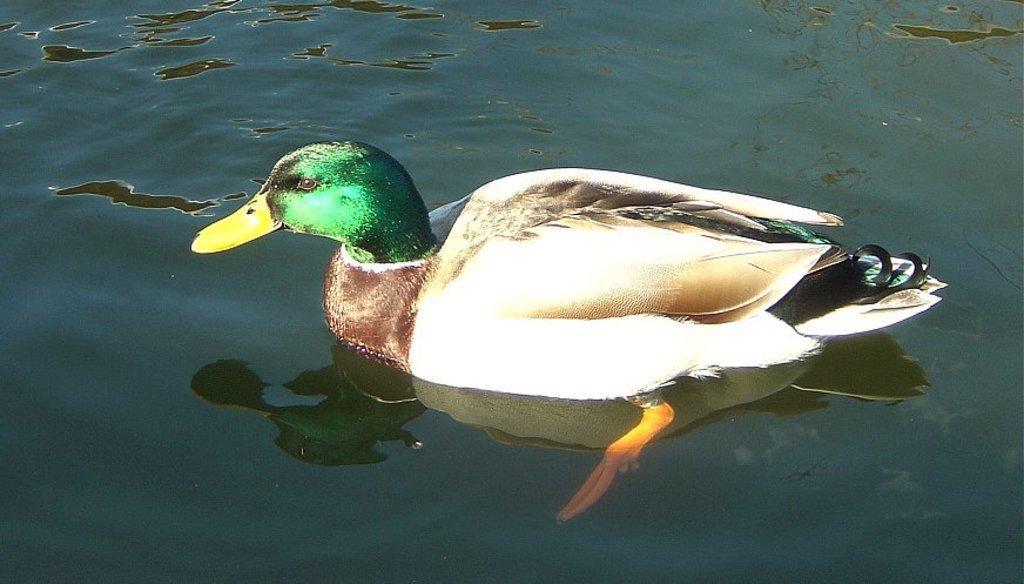In one or two sentences, can you explain what this image depicts? In this picture there is duck on the water and there is reflection of duck on the water. 